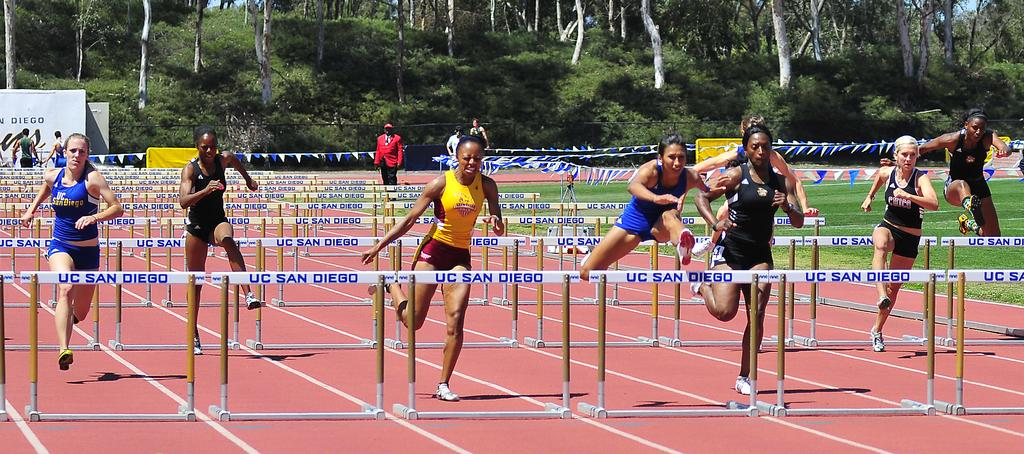<image>
Write a terse but informative summary of the picture. a bunch of runners are going over hurdles labeled UC San Diego 